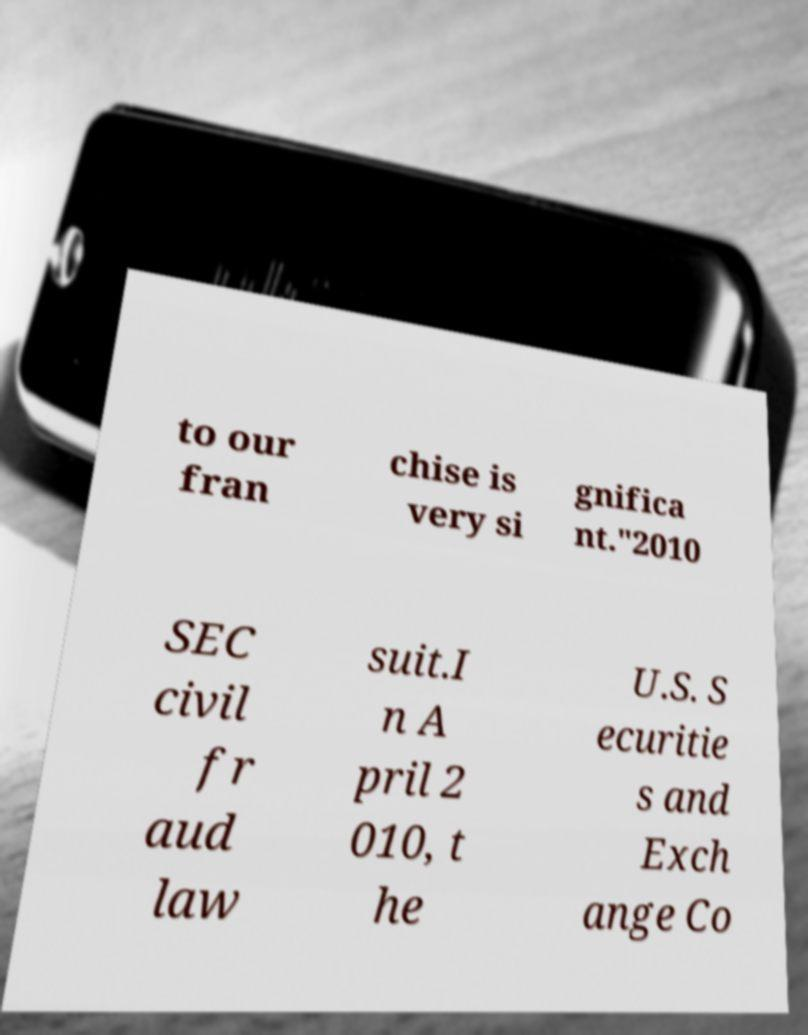Could you extract and type out the text from this image? to our fran chise is very si gnifica nt."2010 SEC civil fr aud law suit.I n A pril 2 010, t he U.S. S ecuritie s and Exch ange Co 